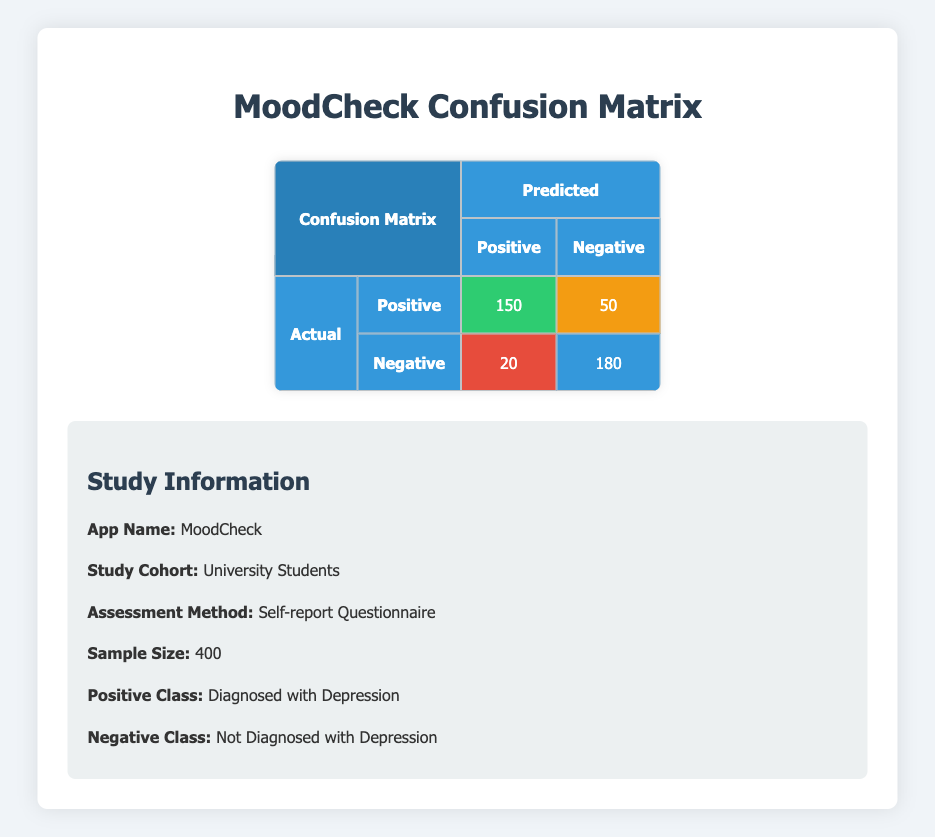What is the total number of True Positives? The True Positives are clearly labeled in the confusion matrix as 150. This value directly indicates the number of individuals correctly diagnosed with depression.
Answer: 150 What is the total number of False Negatives? The False Negatives are shown in the matrix as 50. This figure represents individuals who actually have depression but were not diagnosed correctly by the app.
Answer: 50 What is the total number of individuals diagnosed as Positive? To find the total diagnosed as Positive, we need to add True Positives (150) and False Positives (20). Thus, the total is 150 + 20 = 170.
Answer: 170 Is the number of True Negatives greater than the number of False Positives? The number of True Negatives is 180, and the number of False Positives is 20. Since 180 is greater than 20, this statement is true.
Answer: Yes What percentage of the total sample were True Positives? To calculate the percentage of True Positives, we divide the number of True Positives (150) by the total sample size (400) and multiply by 100: (150 / 400) * 100 = 37.5%.
Answer: 37.5% What is the total number of incorrect diagnoses (False Positives and False Negatives combined)? The total number of incorrect diagnoses is obtained by adding False Positives (20) and False Negatives (50): 20 + 50 = 70.
Answer: 70 How many individuals were classified as Negative? To find the total classified as Negative, we add True Negatives (180) and False Negatives (50): 180 + 50 = 230.
Answer: 230 If the app has a 97.5% accuracy rate, can we infer that it performs well in diagnosing depression among university students? The app's performance can be assessed through its diagnostic accuracy, which includes True Positives and True Negatives. Here, the accuracy can be calculated as (True Positives + True Negatives) / Total = (150 + 180) / 400 = 82.5%. Since 82.5% is significantly below 97.5%, we cannot infer that it performs exceptionally well.
Answer: No 